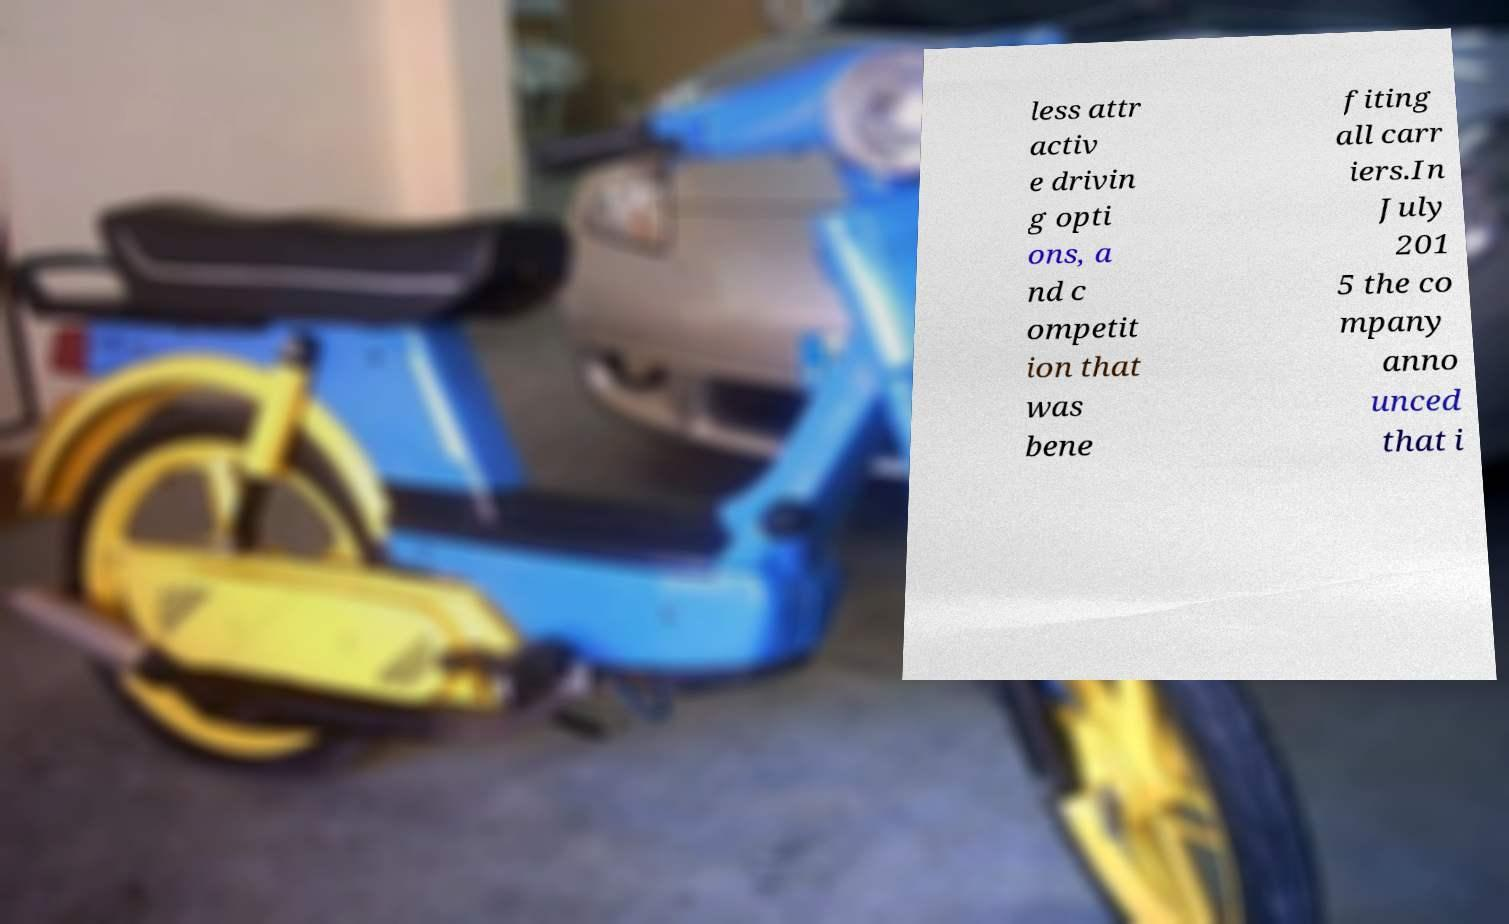I need the written content from this picture converted into text. Can you do that? less attr activ e drivin g opti ons, a nd c ompetit ion that was bene fiting all carr iers.In July 201 5 the co mpany anno unced that i 